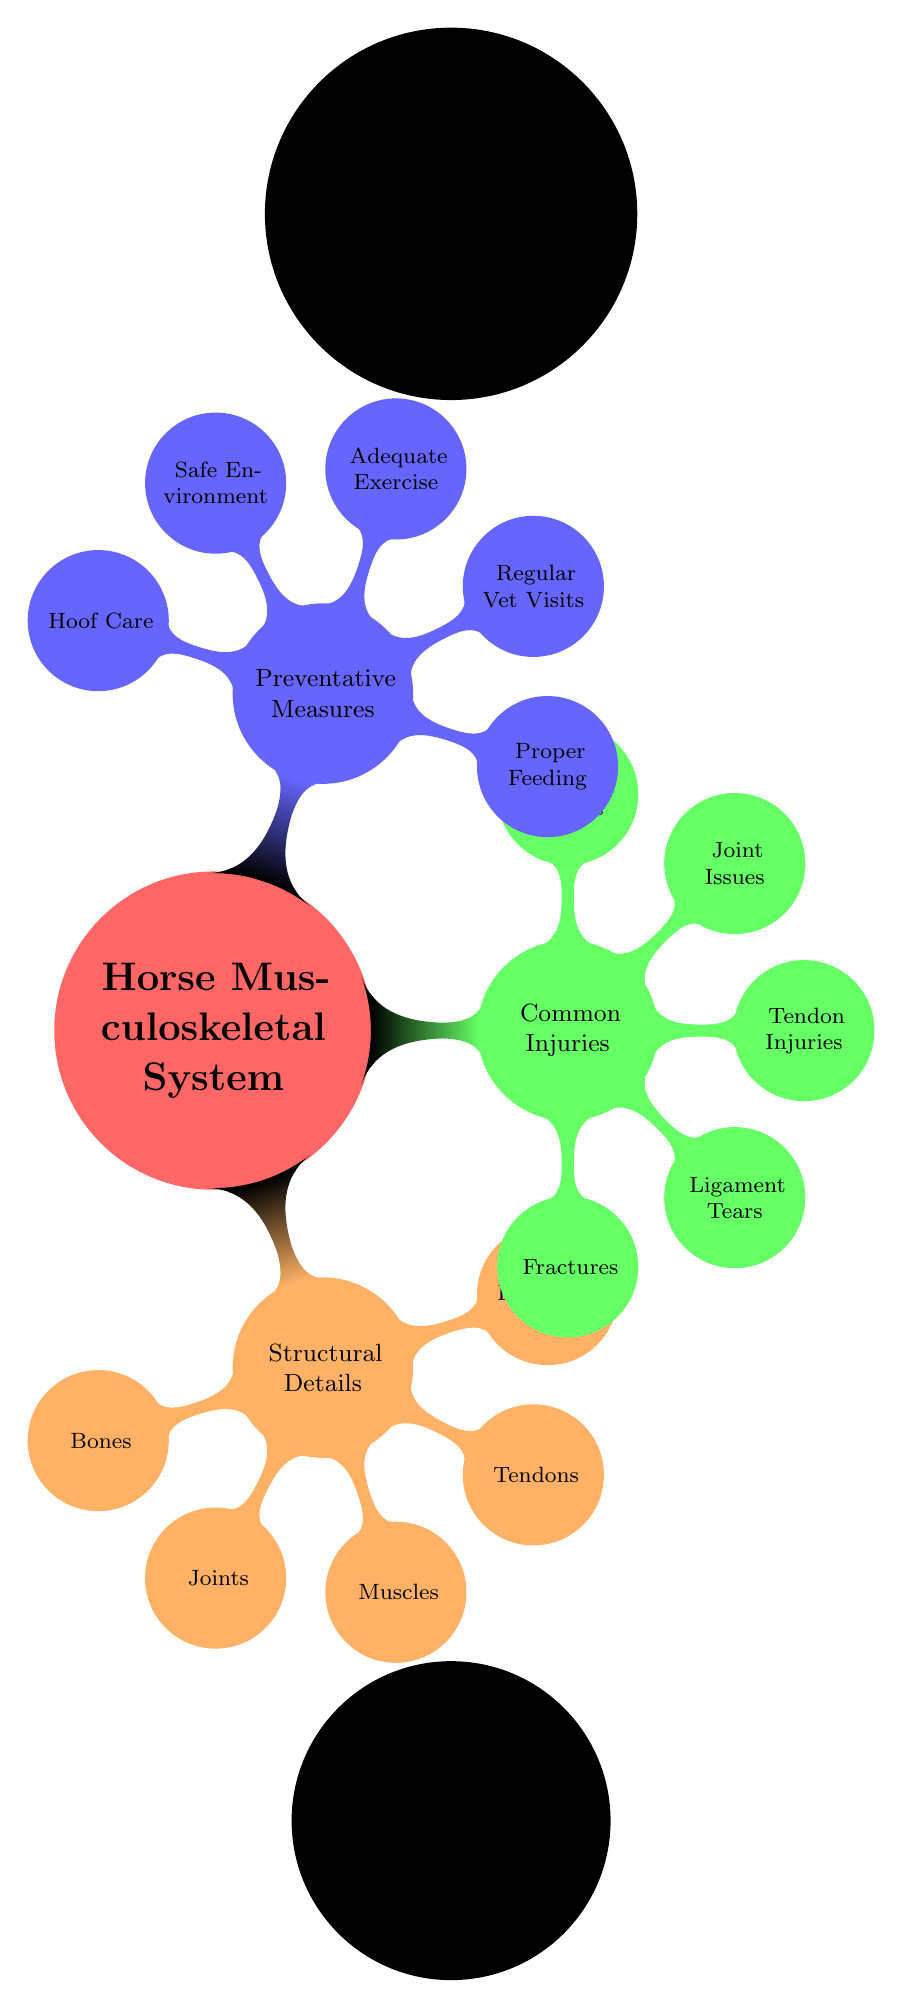What is the primary focus of the diagram? The central node labeled "Horse Musculoskeletal System" indicates that the diagram focuses on the components that make up the musculoskeletal system of horses.
Answer: Horse Musculoskeletal System How many categories of information are presented in the diagram? There are three main child nodes branching from the central node: "Structural Details," "Common Injuries," and "Preventative Measures," indicating three categories.
Answer: 3 Which category includes 'Fractures'? The category "Common Injuries" includes 'Fractures' as one of its child nodes.
Answer: Common Injuries What is a preventative measure listed in the diagram? The diagram lists 'Proper Feeding,' which is categorized under "Preventative Measures" aimed at maintaining horse health.
Answer: Proper Feeding List the components under 'Structural Details'. The components under 'Structural Details' are 'Bones,' 'Joints,' 'Muscles,' 'Tendons,' and 'Ligaments.' This can be derived from the child nodes linked to this category.
Answer: Bones, Joints, Muscles, Tendons, Ligaments How many types of injuries are mentioned in the diagram? The "Common Injuries" category contains five types of injuries: 'Fractures,' 'Ligament Tears,' 'Tendon Injuries,' 'Joint Issues,' and 'Muscle Strains.' Thus, the total count is five.
Answer: 5 Which type of injury is related to the connective tissue? 'Ligament Tears' are related to connective tissue injuries, as ligaments primarily connect bones at joints.
Answer: Ligament Tears Which preventative measure relates to horse living conditions? 'Safe Environment' refers to the living conditions of horses and how they can impact their health and safety.
Answer: Safe Environment Explain the relationship between 'Joints' and 'Muscle Strains'. 'Joints' fall under the 'Structural Details,' while 'Muscle Strains' are classified as a 'Common Injury.' Muscle strains can occur around joints which indicates an indirect relationship, as strained muscles can involve or affect joint function.
Answer: Indirect relationship 